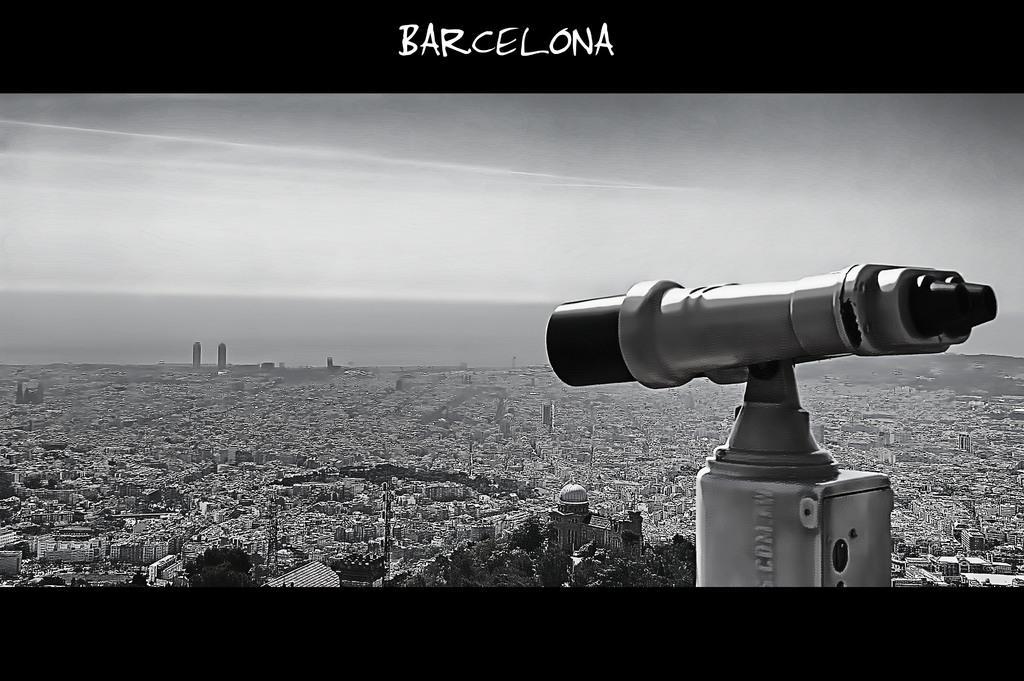Can you describe this image briefly? Here in this picture we can see a telescope present in the front and in front of it we can see buildings present all over there and we can see clouds in sky over there. 